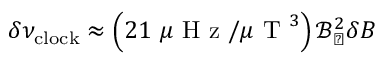<formula> <loc_0><loc_0><loc_500><loc_500>\delta \nu _ { c l o c k } \approx \left ( 2 1 \mu H z / \mu T ^ { 3 } \right ) \mathcal { B } _ { \perp } ^ { 2 } \delta B</formula> 